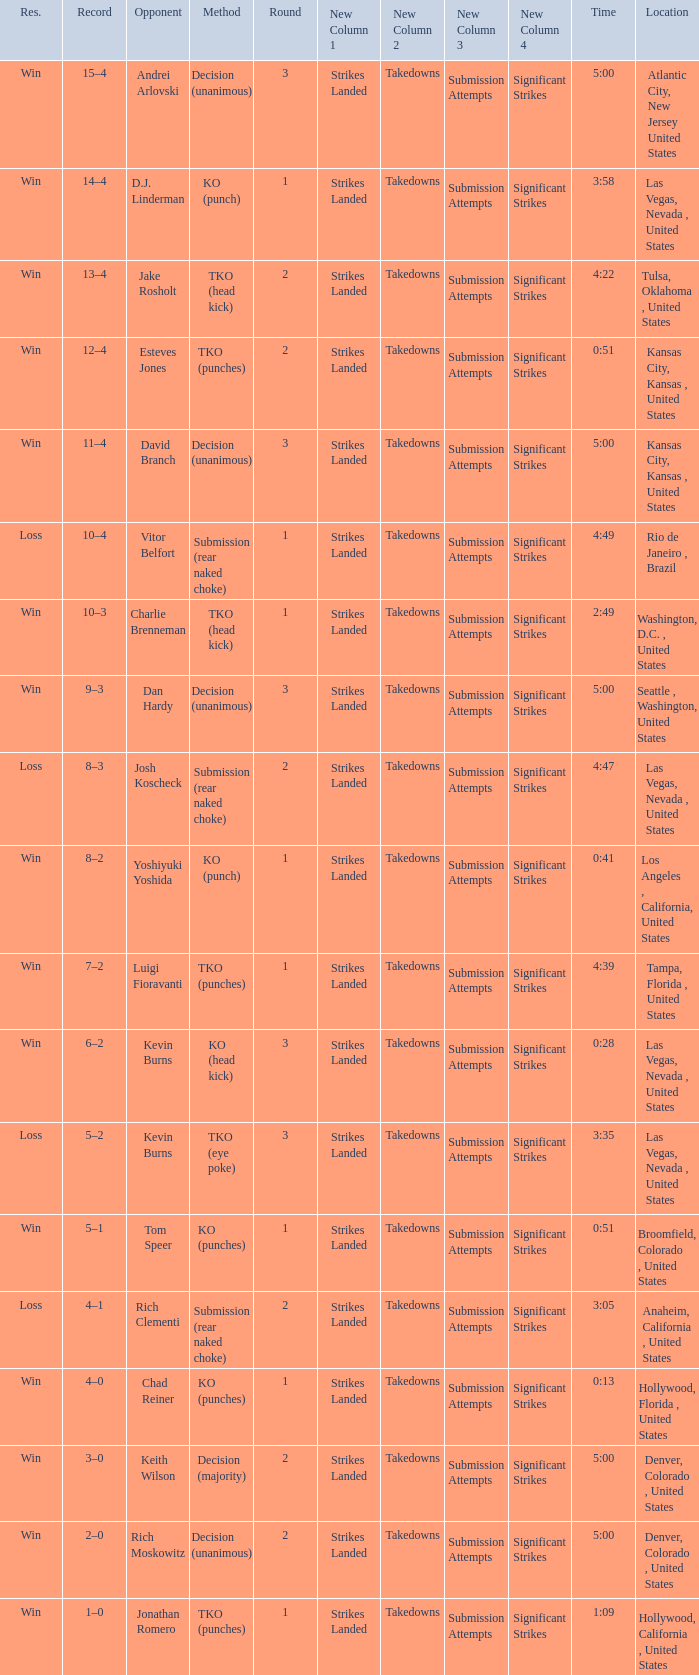What is the largest round number that can be achieved with a time of 4:39? 1.0. 